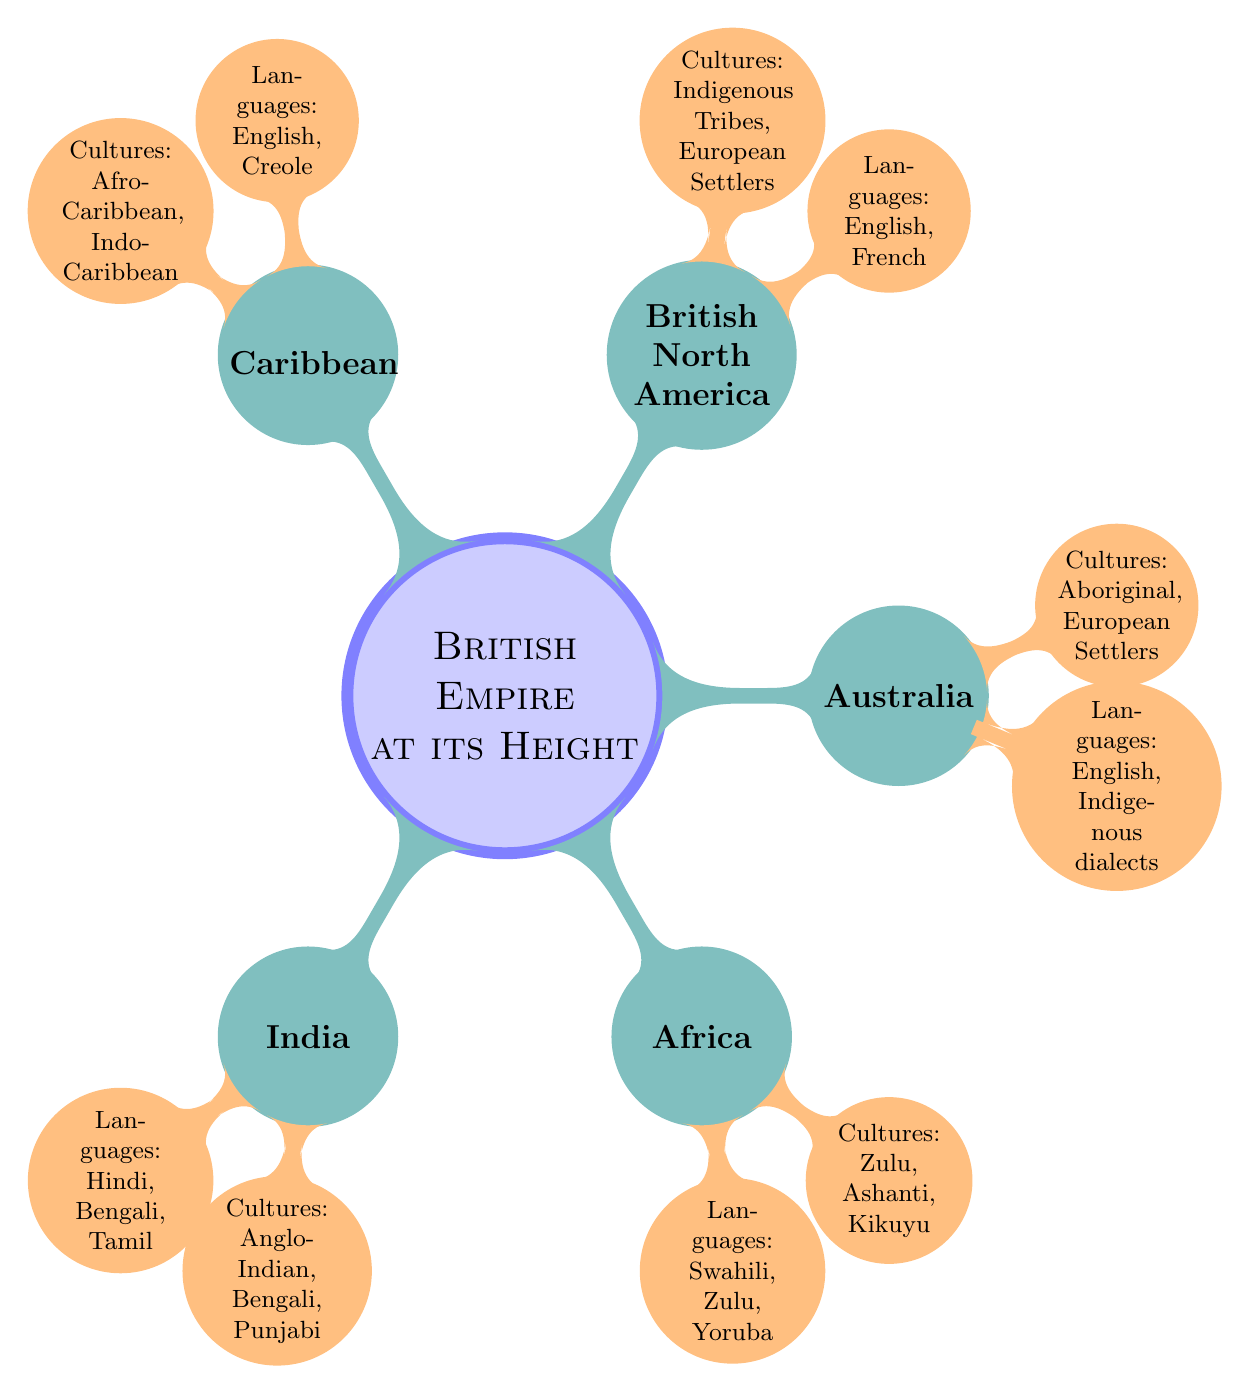What is the root concept of the diagram? The root concept is the main topic or central idea of the diagram. In this case, it's labeled as "British Empire at its Height," which serves as the foundation for all other information related to the British Empire presented in the diagram.
Answer: British Empire at its Height How many main geographic regions are represented? The diagram has five main geographic regions branching from the root concept: India, Africa, Australia, British North America, and the Caribbean. Each of these regions contains further subdivisions about languages and cultures.
Answer: 5 What languages are spoken in India? Directly connected to the India node, the languages are specified as "Hindi, Bengali, Tamil." These languages represent the linguistic diversity present in the region during the time of the British Empire.
Answer: Hindi, Bengali, Tamil Which culture is associated with Africa? The Africa node has a child node that specifies several cultures. Among them, "Zulu" is explicitly mentioned, representing one of the prominent cultures in the African region under British control.
Answer: Zulu Which two languages are spoken in British North America? The node that describes British North America lists the languages as "English, French." This indicates the linguistic characteristics of the region where British influence was prominent.
Answer: English, French Identify a language associated with the Caribbean. The Caribbean region in the diagram is linked to the languages "English, Creole." This indicates the linguistic influences in the Caribbean, particularly during the British imperial period.
Answer: English, Creole Which cultures are linked to Australia? To determine the cultures associated with Australia, we review the connected node, which mentions "Aboriginal, European Settlers." These cultures reflect the indigenous peoples and colonial populations in Australia.
Answer: Aboriginal, European Settlers In terms of cultures, which region has the most diversity? To answer this, we analyze the nodes for each region. All regions mention multiple cultures, but Africa with "Zulu, Ashanti, Kikuyu" can be considered as having rich cultural diversity given the variety listed.
Answer: Africa What is the relationship between languages and cultures in the diagram? The diagram illustrates a direct relationship where each geographic region has associated languages and cultures as child nodes. This shows that languages and cultures coexist and represent the demographic composition of each region within the British Empire.
Answer: Direct relationship 